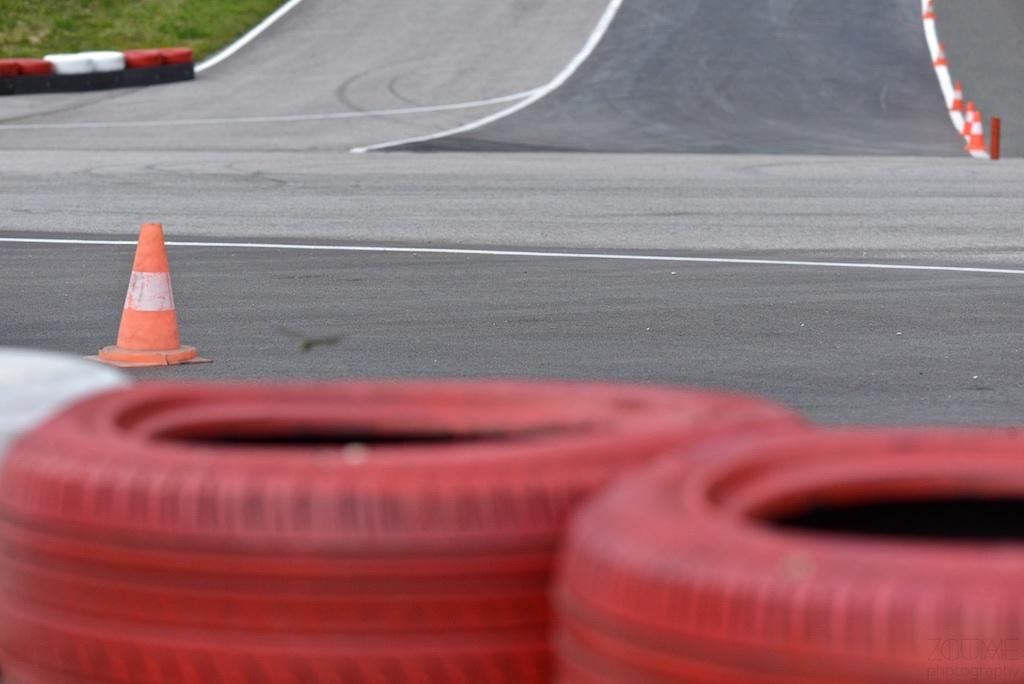What objects can be seen in the image related to traffic or vehicles? There are tyres and traffic cones in the image. What type of surface is visible in the image? There is a road in the image. What type of vegetation is present in the image? There is grass in the image. What type of bone can be seen in the image? There is no bone present in the image. How many eggs are visible in the image? There are no eggs visible in the image. 